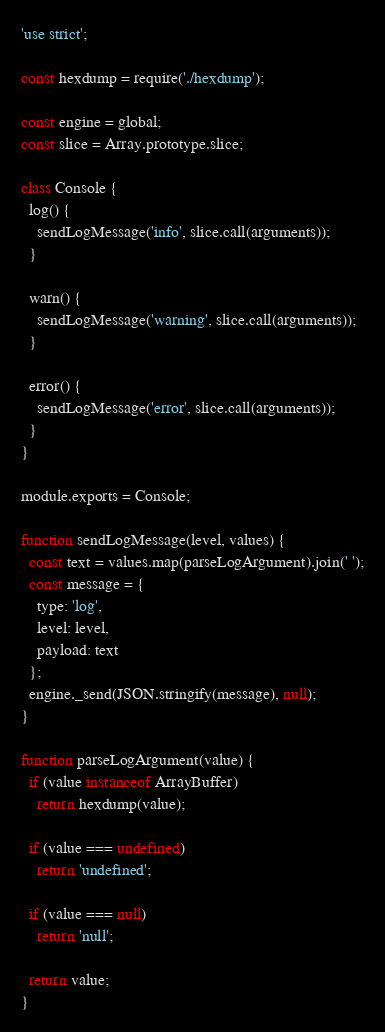Convert code to text. <code><loc_0><loc_0><loc_500><loc_500><_JavaScript_>'use strict';

const hexdump = require('./hexdump');

const engine = global;
const slice = Array.prototype.slice;

class Console {
  log() {
    sendLogMessage('info', slice.call(arguments));
  }

  warn() {
    sendLogMessage('warning', slice.call(arguments));
  }

  error() {
    sendLogMessage('error', slice.call(arguments));
  }
}

module.exports = Console;

function sendLogMessage(level, values) {
  const text = values.map(parseLogArgument).join(' ');
  const message = {
    type: 'log',
    level: level,
    payload: text
  };
  engine._send(JSON.stringify(message), null);
}

function parseLogArgument(value) {
  if (value instanceof ArrayBuffer)
    return hexdump(value);

  if (value === undefined)
    return 'undefined';

  if (value === null)
    return 'null';

  return value;
}
</code> 